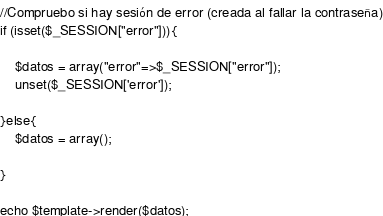Convert code to text. <code><loc_0><loc_0><loc_500><loc_500><_PHP_>//Compruebo si hay sesión de error (creada al fallar la contraseña)
if (isset($_SESSION["error"])){
    
    $datos = array("error"=>$_SESSION["error"]);
    unset($_SESSION['error']);

}else{
	$datos = array();
	
}

echo $template->render($datos);

</code> 